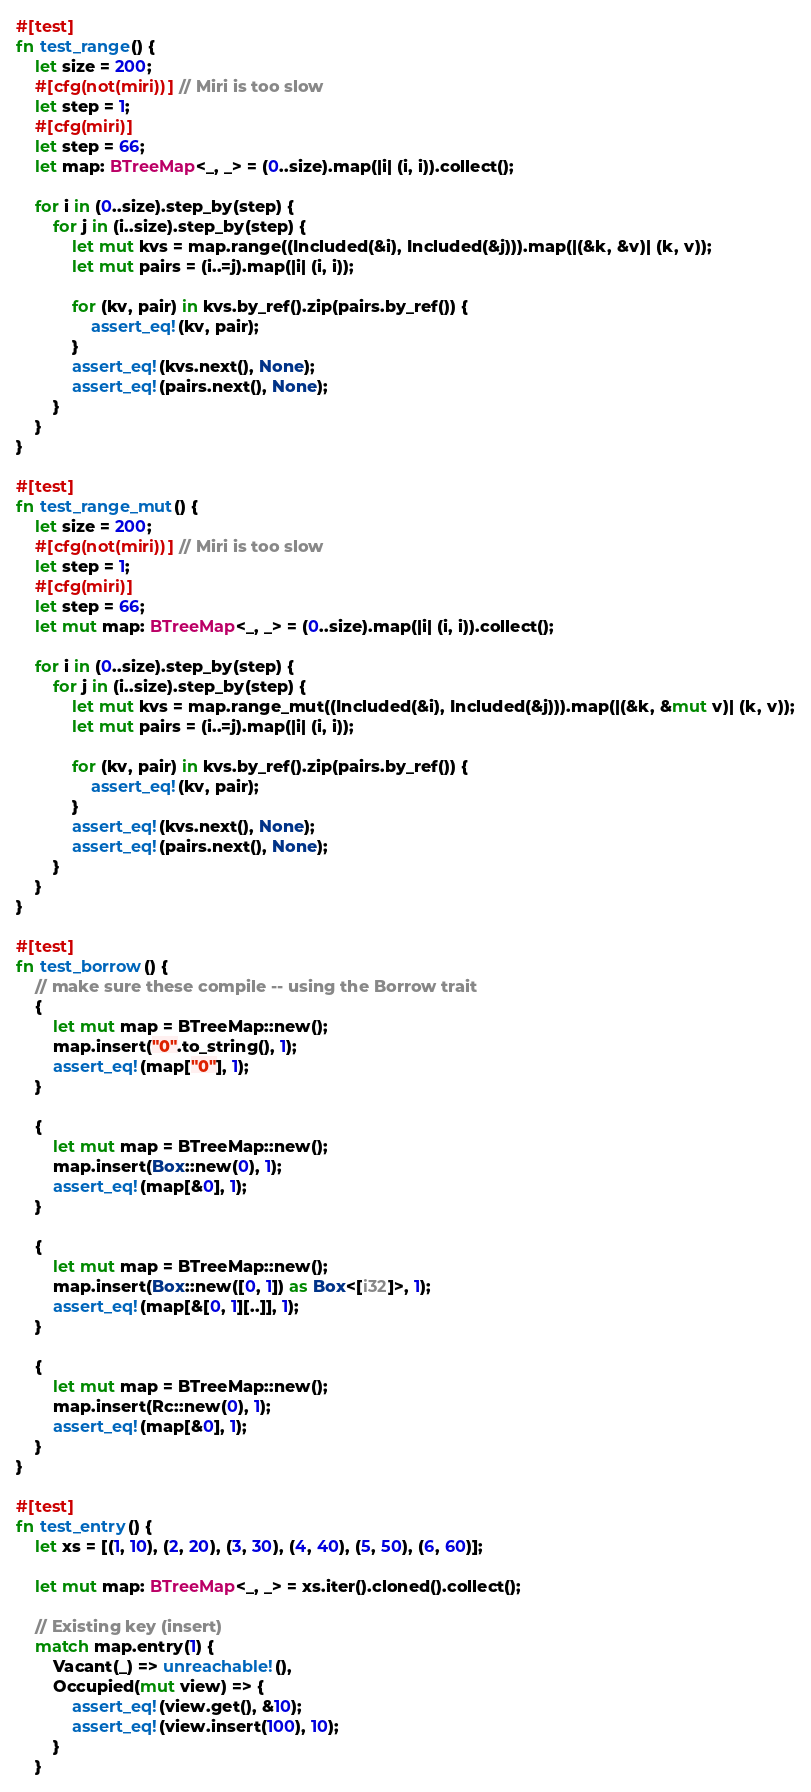<code> <loc_0><loc_0><loc_500><loc_500><_Rust_>#[test]
fn test_range() {
    let size = 200;
    #[cfg(not(miri))] // Miri is too slow
    let step = 1;
    #[cfg(miri)]
    let step = 66;
    let map: BTreeMap<_, _> = (0..size).map(|i| (i, i)).collect();

    for i in (0..size).step_by(step) {
        for j in (i..size).step_by(step) {
            let mut kvs = map.range((Included(&i), Included(&j))).map(|(&k, &v)| (k, v));
            let mut pairs = (i..=j).map(|i| (i, i));

            for (kv, pair) in kvs.by_ref().zip(pairs.by_ref()) {
                assert_eq!(kv, pair);
            }
            assert_eq!(kvs.next(), None);
            assert_eq!(pairs.next(), None);
        }
    }
}

#[test]
fn test_range_mut() {
    let size = 200;
    #[cfg(not(miri))] // Miri is too slow
    let step = 1;
    #[cfg(miri)]
    let step = 66;
    let mut map: BTreeMap<_, _> = (0..size).map(|i| (i, i)).collect();

    for i in (0..size).step_by(step) {
        for j in (i..size).step_by(step) {
            let mut kvs = map.range_mut((Included(&i), Included(&j))).map(|(&k, &mut v)| (k, v));
            let mut pairs = (i..=j).map(|i| (i, i));

            for (kv, pair) in kvs.by_ref().zip(pairs.by_ref()) {
                assert_eq!(kv, pair);
            }
            assert_eq!(kvs.next(), None);
            assert_eq!(pairs.next(), None);
        }
    }
}

#[test]
fn test_borrow() {
    // make sure these compile -- using the Borrow trait
    {
        let mut map = BTreeMap::new();
        map.insert("0".to_string(), 1);
        assert_eq!(map["0"], 1);
    }

    {
        let mut map = BTreeMap::new();
        map.insert(Box::new(0), 1);
        assert_eq!(map[&0], 1);
    }

    {
        let mut map = BTreeMap::new();
        map.insert(Box::new([0, 1]) as Box<[i32]>, 1);
        assert_eq!(map[&[0, 1][..]], 1);
    }

    {
        let mut map = BTreeMap::new();
        map.insert(Rc::new(0), 1);
        assert_eq!(map[&0], 1);
    }
}

#[test]
fn test_entry() {
    let xs = [(1, 10), (2, 20), (3, 30), (4, 40), (5, 50), (6, 60)];

    let mut map: BTreeMap<_, _> = xs.iter().cloned().collect();

    // Existing key (insert)
    match map.entry(1) {
        Vacant(_) => unreachable!(),
        Occupied(mut view) => {
            assert_eq!(view.get(), &10);
            assert_eq!(view.insert(100), 10);
        }
    }</code> 